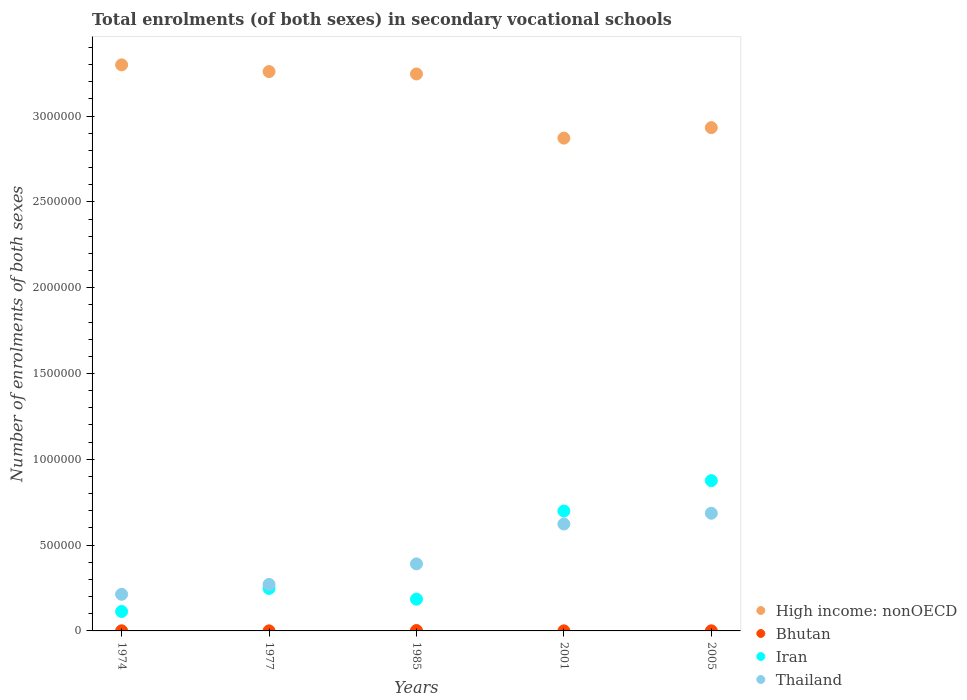How many different coloured dotlines are there?
Offer a very short reply. 4. Is the number of dotlines equal to the number of legend labels?
Your answer should be very brief. Yes. What is the number of enrolments in secondary schools in Bhutan in 2005?
Your response must be concise. 630. Across all years, what is the maximum number of enrolments in secondary schools in Thailand?
Your answer should be very brief. 6.86e+05. Across all years, what is the minimum number of enrolments in secondary schools in Thailand?
Give a very brief answer. 2.13e+05. In which year was the number of enrolments in secondary schools in Iran maximum?
Provide a succinct answer. 2005. In which year was the number of enrolments in secondary schools in Iran minimum?
Your answer should be compact. 1974. What is the total number of enrolments in secondary schools in Iran in the graph?
Give a very brief answer. 2.12e+06. What is the difference between the number of enrolments in secondary schools in High income: nonOECD in 1974 and that in 1985?
Offer a terse response. 5.31e+04. What is the difference between the number of enrolments in secondary schools in Thailand in 1985 and the number of enrolments in secondary schools in Bhutan in 2001?
Offer a very short reply. 3.90e+05. What is the average number of enrolments in secondary schools in Thailand per year?
Your answer should be very brief. 4.37e+05. In the year 2001, what is the difference between the number of enrolments in secondary schools in Bhutan and number of enrolments in secondary schools in High income: nonOECD?
Offer a terse response. -2.87e+06. In how many years, is the number of enrolments in secondary schools in Bhutan greater than 1400000?
Your answer should be very brief. 0. What is the ratio of the number of enrolments in secondary schools in Bhutan in 1974 to that in 2005?
Make the answer very short. 1.17. Is the number of enrolments in secondary schools in High income: nonOECD in 1974 less than that in 1977?
Keep it short and to the point. No. What is the difference between the highest and the second highest number of enrolments in secondary schools in Iran?
Provide a short and direct response. 1.77e+05. What is the difference between the highest and the lowest number of enrolments in secondary schools in Thailand?
Give a very brief answer. 4.72e+05. In how many years, is the number of enrolments in secondary schools in Bhutan greater than the average number of enrolments in secondary schools in Bhutan taken over all years?
Your answer should be compact. 1. Is the sum of the number of enrolments in secondary schools in Thailand in 1985 and 2005 greater than the maximum number of enrolments in secondary schools in Iran across all years?
Give a very brief answer. Yes. Is it the case that in every year, the sum of the number of enrolments in secondary schools in High income: nonOECD and number of enrolments in secondary schools in Bhutan  is greater than the number of enrolments in secondary schools in Thailand?
Your response must be concise. Yes. Does the number of enrolments in secondary schools in High income: nonOECD monotonically increase over the years?
Provide a succinct answer. No. Is the number of enrolments in secondary schools in Iran strictly less than the number of enrolments in secondary schools in High income: nonOECD over the years?
Keep it short and to the point. Yes. How many dotlines are there?
Your response must be concise. 4. How many years are there in the graph?
Give a very brief answer. 5. What is the difference between two consecutive major ticks on the Y-axis?
Give a very brief answer. 5.00e+05. Where does the legend appear in the graph?
Provide a short and direct response. Bottom right. What is the title of the graph?
Your answer should be very brief. Total enrolments (of both sexes) in secondary vocational schools. What is the label or title of the Y-axis?
Ensure brevity in your answer.  Number of enrolments of both sexes. What is the Number of enrolments of both sexes of High income: nonOECD in 1974?
Keep it short and to the point. 3.30e+06. What is the Number of enrolments of both sexes of Bhutan in 1974?
Keep it short and to the point. 734. What is the Number of enrolments of both sexes in Iran in 1974?
Your response must be concise. 1.13e+05. What is the Number of enrolments of both sexes in Thailand in 1974?
Offer a very short reply. 2.13e+05. What is the Number of enrolments of both sexes in High income: nonOECD in 1977?
Your answer should be compact. 3.26e+06. What is the Number of enrolments of both sexes of Bhutan in 1977?
Ensure brevity in your answer.  367. What is the Number of enrolments of both sexes of Iran in 1977?
Offer a terse response. 2.47e+05. What is the Number of enrolments of both sexes of Thailand in 1977?
Make the answer very short. 2.71e+05. What is the Number of enrolments of both sexes of High income: nonOECD in 1985?
Offer a terse response. 3.25e+06. What is the Number of enrolments of both sexes in Bhutan in 1985?
Give a very brief answer. 2314. What is the Number of enrolments of both sexes of Iran in 1985?
Offer a terse response. 1.85e+05. What is the Number of enrolments of both sexes of Thailand in 1985?
Your answer should be compact. 3.91e+05. What is the Number of enrolments of both sexes in High income: nonOECD in 2001?
Your response must be concise. 2.87e+06. What is the Number of enrolments of both sexes in Bhutan in 2001?
Ensure brevity in your answer.  444. What is the Number of enrolments of both sexes in Iran in 2001?
Your response must be concise. 6.99e+05. What is the Number of enrolments of both sexes in Thailand in 2001?
Offer a terse response. 6.23e+05. What is the Number of enrolments of both sexes in High income: nonOECD in 2005?
Provide a short and direct response. 2.93e+06. What is the Number of enrolments of both sexes in Bhutan in 2005?
Give a very brief answer. 630. What is the Number of enrolments of both sexes of Iran in 2005?
Provide a short and direct response. 8.76e+05. What is the Number of enrolments of both sexes of Thailand in 2005?
Keep it short and to the point. 6.86e+05. Across all years, what is the maximum Number of enrolments of both sexes in High income: nonOECD?
Your answer should be very brief. 3.30e+06. Across all years, what is the maximum Number of enrolments of both sexes in Bhutan?
Offer a very short reply. 2314. Across all years, what is the maximum Number of enrolments of both sexes in Iran?
Give a very brief answer. 8.76e+05. Across all years, what is the maximum Number of enrolments of both sexes of Thailand?
Offer a very short reply. 6.86e+05. Across all years, what is the minimum Number of enrolments of both sexes of High income: nonOECD?
Offer a very short reply. 2.87e+06. Across all years, what is the minimum Number of enrolments of both sexes of Bhutan?
Your answer should be compact. 367. Across all years, what is the minimum Number of enrolments of both sexes in Iran?
Your answer should be very brief. 1.13e+05. Across all years, what is the minimum Number of enrolments of both sexes in Thailand?
Your answer should be compact. 2.13e+05. What is the total Number of enrolments of both sexes of High income: nonOECD in the graph?
Keep it short and to the point. 1.56e+07. What is the total Number of enrolments of both sexes of Bhutan in the graph?
Keep it short and to the point. 4489. What is the total Number of enrolments of both sexes in Iran in the graph?
Offer a terse response. 2.12e+06. What is the total Number of enrolments of both sexes of Thailand in the graph?
Give a very brief answer. 2.18e+06. What is the difference between the Number of enrolments of both sexes in High income: nonOECD in 1974 and that in 1977?
Your response must be concise. 3.89e+04. What is the difference between the Number of enrolments of both sexes in Bhutan in 1974 and that in 1977?
Offer a very short reply. 367. What is the difference between the Number of enrolments of both sexes in Iran in 1974 and that in 1977?
Keep it short and to the point. -1.34e+05. What is the difference between the Number of enrolments of both sexes in Thailand in 1974 and that in 1977?
Offer a terse response. -5.75e+04. What is the difference between the Number of enrolments of both sexes in High income: nonOECD in 1974 and that in 1985?
Offer a very short reply. 5.31e+04. What is the difference between the Number of enrolments of both sexes in Bhutan in 1974 and that in 1985?
Provide a short and direct response. -1580. What is the difference between the Number of enrolments of both sexes of Iran in 1974 and that in 1985?
Your answer should be compact. -7.16e+04. What is the difference between the Number of enrolments of both sexes of Thailand in 1974 and that in 1985?
Ensure brevity in your answer.  -1.77e+05. What is the difference between the Number of enrolments of both sexes in High income: nonOECD in 1974 and that in 2001?
Offer a terse response. 4.27e+05. What is the difference between the Number of enrolments of both sexes of Bhutan in 1974 and that in 2001?
Offer a very short reply. 290. What is the difference between the Number of enrolments of both sexes in Iran in 1974 and that in 2001?
Offer a terse response. -5.85e+05. What is the difference between the Number of enrolments of both sexes of Thailand in 1974 and that in 2001?
Ensure brevity in your answer.  -4.10e+05. What is the difference between the Number of enrolments of both sexes in High income: nonOECD in 1974 and that in 2005?
Provide a short and direct response. 3.66e+05. What is the difference between the Number of enrolments of both sexes of Bhutan in 1974 and that in 2005?
Offer a terse response. 104. What is the difference between the Number of enrolments of both sexes in Iran in 1974 and that in 2005?
Your response must be concise. -7.62e+05. What is the difference between the Number of enrolments of both sexes in Thailand in 1974 and that in 2005?
Provide a short and direct response. -4.72e+05. What is the difference between the Number of enrolments of both sexes in High income: nonOECD in 1977 and that in 1985?
Give a very brief answer. 1.41e+04. What is the difference between the Number of enrolments of both sexes in Bhutan in 1977 and that in 1985?
Ensure brevity in your answer.  -1947. What is the difference between the Number of enrolments of both sexes in Iran in 1977 and that in 1985?
Make the answer very short. 6.25e+04. What is the difference between the Number of enrolments of both sexes of Thailand in 1977 and that in 1985?
Ensure brevity in your answer.  -1.20e+05. What is the difference between the Number of enrolments of both sexes of High income: nonOECD in 1977 and that in 2001?
Your answer should be compact. 3.88e+05. What is the difference between the Number of enrolments of both sexes in Bhutan in 1977 and that in 2001?
Your answer should be compact. -77. What is the difference between the Number of enrolments of both sexes in Iran in 1977 and that in 2001?
Your response must be concise. -4.51e+05. What is the difference between the Number of enrolments of both sexes in Thailand in 1977 and that in 2001?
Your answer should be compact. -3.52e+05. What is the difference between the Number of enrolments of both sexes of High income: nonOECD in 1977 and that in 2005?
Provide a short and direct response. 3.27e+05. What is the difference between the Number of enrolments of both sexes in Bhutan in 1977 and that in 2005?
Give a very brief answer. -263. What is the difference between the Number of enrolments of both sexes in Iran in 1977 and that in 2005?
Your answer should be very brief. -6.28e+05. What is the difference between the Number of enrolments of both sexes of Thailand in 1977 and that in 2005?
Ensure brevity in your answer.  -4.15e+05. What is the difference between the Number of enrolments of both sexes of High income: nonOECD in 1985 and that in 2001?
Your answer should be very brief. 3.74e+05. What is the difference between the Number of enrolments of both sexes in Bhutan in 1985 and that in 2001?
Provide a short and direct response. 1870. What is the difference between the Number of enrolments of both sexes of Iran in 1985 and that in 2001?
Provide a succinct answer. -5.14e+05. What is the difference between the Number of enrolments of both sexes in Thailand in 1985 and that in 2001?
Your answer should be compact. -2.32e+05. What is the difference between the Number of enrolments of both sexes in High income: nonOECD in 1985 and that in 2005?
Provide a succinct answer. 3.13e+05. What is the difference between the Number of enrolments of both sexes in Bhutan in 1985 and that in 2005?
Keep it short and to the point. 1684. What is the difference between the Number of enrolments of both sexes of Iran in 1985 and that in 2005?
Offer a very short reply. -6.91e+05. What is the difference between the Number of enrolments of both sexes in Thailand in 1985 and that in 2005?
Your answer should be compact. -2.95e+05. What is the difference between the Number of enrolments of both sexes in High income: nonOECD in 2001 and that in 2005?
Make the answer very short. -6.12e+04. What is the difference between the Number of enrolments of both sexes of Bhutan in 2001 and that in 2005?
Make the answer very short. -186. What is the difference between the Number of enrolments of both sexes of Iran in 2001 and that in 2005?
Provide a succinct answer. -1.77e+05. What is the difference between the Number of enrolments of both sexes of Thailand in 2001 and that in 2005?
Give a very brief answer. -6.27e+04. What is the difference between the Number of enrolments of both sexes of High income: nonOECD in 1974 and the Number of enrolments of both sexes of Bhutan in 1977?
Keep it short and to the point. 3.30e+06. What is the difference between the Number of enrolments of both sexes in High income: nonOECD in 1974 and the Number of enrolments of both sexes in Iran in 1977?
Your response must be concise. 3.05e+06. What is the difference between the Number of enrolments of both sexes of High income: nonOECD in 1974 and the Number of enrolments of both sexes of Thailand in 1977?
Make the answer very short. 3.03e+06. What is the difference between the Number of enrolments of both sexes in Bhutan in 1974 and the Number of enrolments of both sexes in Iran in 1977?
Offer a terse response. -2.47e+05. What is the difference between the Number of enrolments of both sexes in Bhutan in 1974 and the Number of enrolments of both sexes in Thailand in 1977?
Keep it short and to the point. -2.70e+05. What is the difference between the Number of enrolments of both sexes of Iran in 1974 and the Number of enrolments of both sexes of Thailand in 1977?
Your answer should be very brief. -1.58e+05. What is the difference between the Number of enrolments of both sexes of High income: nonOECD in 1974 and the Number of enrolments of both sexes of Bhutan in 1985?
Your answer should be compact. 3.30e+06. What is the difference between the Number of enrolments of both sexes in High income: nonOECD in 1974 and the Number of enrolments of both sexes in Iran in 1985?
Make the answer very short. 3.11e+06. What is the difference between the Number of enrolments of both sexes in High income: nonOECD in 1974 and the Number of enrolments of both sexes in Thailand in 1985?
Your answer should be compact. 2.91e+06. What is the difference between the Number of enrolments of both sexes of Bhutan in 1974 and the Number of enrolments of both sexes of Iran in 1985?
Offer a terse response. -1.84e+05. What is the difference between the Number of enrolments of both sexes in Bhutan in 1974 and the Number of enrolments of both sexes in Thailand in 1985?
Offer a terse response. -3.90e+05. What is the difference between the Number of enrolments of both sexes of Iran in 1974 and the Number of enrolments of both sexes of Thailand in 1985?
Offer a very short reply. -2.77e+05. What is the difference between the Number of enrolments of both sexes in High income: nonOECD in 1974 and the Number of enrolments of both sexes in Bhutan in 2001?
Keep it short and to the point. 3.30e+06. What is the difference between the Number of enrolments of both sexes in High income: nonOECD in 1974 and the Number of enrolments of both sexes in Iran in 2001?
Your answer should be very brief. 2.60e+06. What is the difference between the Number of enrolments of both sexes in High income: nonOECD in 1974 and the Number of enrolments of both sexes in Thailand in 2001?
Your answer should be compact. 2.68e+06. What is the difference between the Number of enrolments of both sexes in Bhutan in 1974 and the Number of enrolments of both sexes in Iran in 2001?
Give a very brief answer. -6.98e+05. What is the difference between the Number of enrolments of both sexes of Bhutan in 1974 and the Number of enrolments of both sexes of Thailand in 2001?
Ensure brevity in your answer.  -6.22e+05. What is the difference between the Number of enrolments of both sexes in Iran in 1974 and the Number of enrolments of both sexes in Thailand in 2001?
Ensure brevity in your answer.  -5.10e+05. What is the difference between the Number of enrolments of both sexes in High income: nonOECD in 1974 and the Number of enrolments of both sexes in Bhutan in 2005?
Your response must be concise. 3.30e+06. What is the difference between the Number of enrolments of both sexes of High income: nonOECD in 1974 and the Number of enrolments of both sexes of Iran in 2005?
Provide a succinct answer. 2.42e+06. What is the difference between the Number of enrolments of both sexes in High income: nonOECD in 1974 and the Number of enrolments of both sexes in Thailand in 2005?
Your answer should be very brief. 2.61e+06. What is the difference between the Number of enrolments of both sexes of Bhutan in 1974 and the Number of enrolments of both sexes of Iran in 2005?
Offer a very short reply. -8.75e+05. What is the difference between the Number of enrolments of both sexes in Bhutan in 1974 and the Number of enrolments of both sexes in Thailand in 2005?
Keep it short and to the point. -6.85e+05. What is the difference between the Number of enrolments of both sexes of Iran in 1974 and the Number of enrolments of both sexes of Thailand in 2005?
Provide a succinct answer. -5.72e+05. What is the difference between the Number of enrolments of both sexes in High income: nonOECD in 1977 and the Number of enrolments of both sexes in Bhutan in 1985?
Give a very brief answer. 3.26e+06. What is the difference between the Number of enrolments of both sexes in High income: nonOECD in 1977 and the Number of enrolments of both sexes in Iran in 1985?
Make the answer very short. 3.07e+06. What is the difference between the Number of enrolments of both sexes of High income: nonOECD in 1977 and the Number of enrolments of both sexes of Thailand in 1985?
Ensure brevity in your answer.  2.87e+06. What is the difference between the Number of enrolments of both sexes in Bhutan in 1977 and the Number of enrolments of both sexes in Iran in 1985?
Your answer should be very brief. -1.85e+05. What is the difference between the Number of enrolments of both sexes in Bhutan in 1977 and the Number of enrolments of both sexes in Thailand in 1985?
Provide a succinct answer. -3.90e+05. What is the difference between the Number of enrolments of both sexes of Iran in 1977 and the Number of enrolments of both sexes of Thailand in 1985?
Provide a short and direct response. -1.43e+05. What is the difference between the Number of enrolments of both sexes in High income: nonOECD in 1977 and the Number of enrolments of both sexes in Bhutan in 2001?
Your response must be concise. 3.26e+06. What is the difference between the Number of enrolments of both sexes of High income: nonOECD in 1977 and the Number of enrolments of both sexes of Iran in 2001?
Make the answer very short. 2.56e+06. What is the difference between the Number of enrolments of both sexes in High income: nonOECD in 1977 and the Number of enrolments of both sexes in Thailand in 2001?
Give a very brief answer. 2.64e+06. What is the difference between the Number of enrolments of both sexes of Bhutan in 1977 and the Number of enrolments of both sexes of Iran in 2001?
Keep it short and to the point. -6.98e+05. What is the difference between the Number of enrolments of both sexes in Bhutan in 1977 and the Number of enrolments of both sexes in Thailand in 2001?
Make the answer very short. -6.23e+05. What is the difference between the Number of enrolments of both sexes of Iran in 1977 and the Number of enrolments of both sexes of Thailand in 2001?
Your answer should be very brief. -3.76e+05. What is the difference between the Number of enrolments of both sexes of High income: nonOECD in 1977 and the Number of enrolments of both sexes of Bhutan in 2005?
Make the answer very short. 3.26e+06. What is the difference between the Number of enrolments of both sexes in High income: nonOECD in 1977 and the Number of enrolments of both sexes in Iran in 2005?
Your answer should be compact. 2.38e+06. What is the difference between the Number of enrolments of both sexes in High income: nonOECD in 1977 and the Number of enrolments of both sexes in Thailand in 2005?
Ensure brevity in your answer.  2.57e+06. What is the difference between the Number of enrolments of both sexes of Bhutan in 1977 and the Number of enrolments of both sexes of Iran in 2005?
Your answer should be compact. -8.75e+05. What is the difference between the Number of enrolments of both sexes of Bhutan in 1977 and the Number of enrolments of both sexes of Thailand in 2005?
Make the answer very short. -6.85e+05. What is the difference between the Number of enrolments of both sexes of Iran in 1977 and the Number of enrolments of both sexes of Thailand in 2005?
Make the answer very short. -4.38e+05. What is the difference between the Number of enrolments of both sexes of High income: nonOECD in 1985 and the Number of enrolments of both sexes of Bhutan in 2001?
Give a very brief answer. 3.25e+06. What is the difference between the Number of enrolments of both sexes of High income: nonOECD in 1985 and the Number of enrolments of both sexes of Iran in 2001?
Give a very brief answer. 2.55e+06. What is the difference between the Number of enrolments of both sexes in High income: nonOECD in 1985 and the Number of enrolments of both sexes in Thailand in 2001?
Your answer should be very brief. 2.62e+06. What is the difference between the Number of enrolments of both sexes in Bhutan in 1985 and the Number of enrolments of both sexes in Iran in 2001?
Provide a succinct answer. -6.96e+05. What is the difference between the Number of enrolments of both sexes of Bhutan in 1985 and the Number of enrolments of both sexes of Thailand in 2001?
Provide a short and direct response. -6.21e+05. What is the difference between the Number of enrolments of both sexes of Iran in 1985 and the Number of enrolments of both sexes of Thailand in 2001?
Offer a terse response. -4.38e+05. What is the difference between the Number of enrolments of both sexes in High income: nonOECD in 1985 and the Number of enrolments of both sexes in Bhutan in 2005?
Give a very brief answer. 3.24e+06. What is the difference between the Number of enrolments of both sexes of High income: nonOECD in 1985 and the Number of enrolments of both sexes of Iran in 2005?
Offer a very short reply. 2.37e+06. What is the difference between the Number of enrolments of both sexes of High income: nonOECD in 1985 and the Number of enrolments of both sexes of Thailand in 2005?
Offer a very short reply. 2.56e+06. What is the difference between the Number of enrolments of both sexes of Bhutan in 1985 and the Number of enrolments of both sexes of Iran in 2005?
Your answer should be compact. -8.74e+05. What is the difference between the Number of enrolments of both sexes in Bhutan in 1985 and the Number of enrolments of both sexes in Thailand in 2005?
Provide a succinct answer. -6.83e+05. What is the difference between the Number of enrolments of both sexes in Iran in 1985 and the Number of enrolments of both sexes in Thailand in 2005?
Keep it short and to the point. -5.01e+05. What is the difference between the Number of enrolments of both sexes of High income: nonOECD in 2001 and the Number of enrolments of both sexes of Bhutan in 2005?
Your answer should be very brief. 2.87e+06. What is the difference between the Number of enrolments of both sexes in High income: nonOECD in 2001 and the Number of enrolments of both sexes in Iran in 2005?
Make the answer very short. 2.00e+06. What is the difference between the Number of enrolments of both sexes of High income: nonOECD in 2001 and the Number of enrolments of both sexes of Thailand in 2005?
Provide a succinct answer. 2.19e+06. What is the difference between the Number of enrolments of both sexes in Bhutan in 2001 and the Number of enrolments of both sexes in Iran in 2005?
Make the answer very short. -8.75e+05. What is the difference between the Number of enrolments of both sexes of Bhutan in 2001 and the Number of enrolments of both sexes of Thailand in 2005?
Give a very brief answer. -6.85e+05. What is the difference between the Number of enrolments of both sexes of Iran in 2001 and the Number of enrolments of both sexes of Thailand in 2005?
Provide a succinct answer. 1.30e+04. What is the average Number of enrolments of both sexes of High income: nonOECD per year?
Your answer should be very brief. 3.12e+06. What is the average Number of enrolments of both sexes of Bhutan per year?
Make the answer very short. 897.8. What is the average Number of enrolments of both sexes in Iran per year?
Ensure brevity in your answer.  4.24e+05. What is the average Number of enrolments of both sexes of Thailand per year?
Offer a very short reply. 4.37e+05. In the year 1974, what is the difference between the Number of enrolments of both sexes in High income: nonOECD and Number of enrolments of both sexes in Bhutan?
Ensure brevity in your answer.  3.30e+06. In the year 1974, what is the difference between the Number of enrolments of both sexes in High income: nonOECD and Number of enrolments of both sexes in Iran?
Give a very brief answer. 3.19e+06. In the year 1974, what is the difference between the Number of enrolments of both sexes of High income: nonOECD and Number of enrolments of both sexes of Thailand?
Your answer should be very brief. 3.09e+06. In the year 1974, what is the difference between the Number of enrolments of both sexes of Bhutan and Number of enrolments of both sexes of Iran?
Provide a short and direct response. -1.13e+05. In the year 1974, what is the difference between the Number of enrolments of both sexes of Bhutan and Number of enrolments of both sexes of Thailand?
Offer a terse response. -2.13e+05. In the year 1974, what is the difference between the Number of enrolments of both sexes of Iran and Number of enrolments of both sexes of Thailand?
Provide a succinct answer. -1.00e+05. In the year 1977, what is the difference between the Number of enrolments of both sexes of High income: nonOECD and Number of enrolments of both sexes of Bhutan?
Offer a very short reply. 3.26e+06. In the year 1977, what is the difference between the Number of enrolments of both sexes in High income: nonOECD and Number of enrolments of both sexes in Iran?
Give a very brief answer. 3.01e+06. In the year 1977, what is the difference between the Number of enrolments of both sexes of High income: nonOECD and Number of enrolments of both sexes of Thailand?
Ensure brevity in your answer.  2.99e+06. In the year 1977, what is the difference between the Number of enrolments of both sexes in Bhutan and Number of enrolments of both sexes in Iran?
Ensure brevity in your answer.  -2.47e+05. In the year 1977, what is the difference between the Number of enrolments of both sexes of Bhutan and Number of enrolments of both sexes of Thailand?
Your answer should be compact. -2.71e+05. In the year 1977, what is the difference between the Number of enrolments of both sexes in Iran and Number of enrolments of both sexes in Thailand?
Give a very brief answer. -2.34e+04. In the year 1985, what is the difference between the Number of enrolments of both sexes of High income: nonOECD and Number of enrolments of both sexes of Bhutan?
Your answer should be compact. 3.24e+06. In the year 1985, what is the difference between the Number of enrolments of both sexes of High income: nonOECD and Number of enrolments of both sexes of Iran?
Your answer should be very brief. 3.06e+06. In the year 1985, what is the difference between the Number of enrolments of both sexes of High income: nonOECD and Number of enrolments of both sexes of Thailand?
Provide a short and direct response. 2.85e+06. In the year 1985, what is the difference between the Number of enrolments of both sexes of Bhutan and Number of enrolments of both sexes of Iran?
Make the answer very short. -1.83e+05. In the year 1985, what is the difference between the Number of enrolments of both sexes of Bhutan and Number of enrolments of both sexes of Thailand?
Provide a short and direct response. -3.88e+05. In the year 1985, what is the difference between the Number of enrolments of both sexes of Iran and Number of enrolments of both sexes of Thailand?
Your answer should be compact. -2.06e+05. In the year 2001, what is the difference between the Number of enrolments of both sexes of High income: nonOECD and Number of enrolments of both sexes of Bhutan?
Provide a short and direct response. 2.87e+06. In the year 2001, what is the difference between the Number of enrolments of both sexes of High income: nonOECD and Number of enrolments of both sexes of Iran?
Your response must be concise. 2.17e+06. In the year 2001, what is the difference between the Number of enrolments of both sexes of High income: nonOECD and Number of enrolments of both sexes of Thailand?
Provide a succinct answer. 2.25e+06. In the year 2001, what is the difference between the Number of enrolments of both sexes in Bhutan and Number of enrolments of both sexes in Iran?
Your answer should be compact. -6.98e+05. In the year 2001, what is the difference between the Number of enrolments of both sexes of Bhutan and Number of enrolments of both sexes of Thailand?
Your response must be concise. -6.23e+05. In the year 2001, what is the difference between the Number of enrolments of both sexes in Iran and Number of enrolments of both sexes in Thailand?
Offer a very short reply. 7.57e+04. In the year 2005, what is the difference between the Number of enrolments of both sexes in High income: nonOECD and Number of enrolments of both sexes in Bhutan?
Ensure brevity in your answer.  2.93e+06. In the year 2005, what is the difference between the Number of enrolments of both sexes in High income: nonOECD and Number of enrolments of both sexes in Iran?
Provide a short and direct response. 2.06e+06. In the year 2005, what is the difference between the Number of enrolments of both sexes of High income: nonOECD and Number of enrolments of both sexes of Thailand?
Offer a terse response. 2.25e+06. In the year 2005, what is the difference between the Number of enrolments of both sexes of Bhutan and Number of enrolments of both sexes of Iran?
Your response must be concise. -8.75e+05. In the year 2005, what is the difference between the Number of enrolments of both sexes of Bhutan and Number of enrolments of both sexes of Thailand?
Give a very brief answer. -6.85e+05. In the year 2005, what is the difference between the Number of enrolments of both sexes in Iran and Number of enrolments of both sexes in Thailand?
Your response must be concise. 1.90e+05. What is the ratio of the Number of enrolments of both sexes in High income: nonOECD in 1974 to that in 1977?
Offer a terse response. 1.01. What is the ratio of the Number of enrolments of both sexes in Iran in 1974 to that in 1977?
Make the answer very short. 0.46. What is the ratio of the Number of enrolments of both sexes of Thailand in 1974 to that in 1977?
Make the answer very short. 0.79. What is the ratio of the Number of enrolments of both sexes of High income: nonOECD in 1974 to that in 1985?
Provide a short and direct response. 1.02. What is the ratio of the Number of enrolments of both sexes of Bhutan in 1974 to that in 1985?
Offer a very short reply. 0.32. What is the ratio of the Number of enrolments of both sexes of Iran in 1974 to that in 1985?
Your answer should be very brief. 0.61. What is the ratio of the Number of enrolments of both sexes of Thailand in 1974 to that in 1985?
Offer a terse response. 0.55. What is the ratio of the Number of enrolments of both sexes in High income: nonOECD in 1974 to that in 2001?
Your response must be concise. 1.15. What is the ratio of the Number of enrolments of both sexes of Bhutan in 1974 to that in 2001?
Provide a short and direct response. 1.65. What is the ratio of the Number of enrolments of both sexes in Iran in 1974 to that in 2001?
Offer a terse response. 0.16. What is the ratio of the Number of enrolments of both sexes in Thailand in 1974 to that in 2001?
Offer a terse response. 0.34. What is the ratio of the Number of enrolments of both sexes in High income: nonOECD in 1974 to that in 2005?
Give a very brief answer. 1.12. What is the ratio of the Number of enrolments of both sexes of Bhutan in 1974 to that in 2005?
Keep it short and to the point. 1.17. What is the ratio of the Number of enrolments of both sexes in Iran in 1974 to that in 2005?
Ensure brevity in your answer.  0.13. What is the ratio of the Number of enrolments of both sexes of Thailand in 1974 to that in 2005?
Your response must be concise. 0.31. What is the ratio of the Number of enrolments of both sexes in Bhutan in 1977 to that in 1985?
Provide a succinct answer. 0.16. What is the ratio of the Number of enrolments of both sexes in Iran in 1977 to that in 1985?
Your response must be concise. 1.34. What is the ratio of the Number of enrolments of both sexes in Thailand in 1977 to that in 1985?
Make the answer very short. 0.69. What is the ratio of the Number of enrolments of both sexes in High income: nonOECD in 1977 to that in 2001?
Offer a very short reply. 1.14. What is the ratio of the Number of enrolments of both sexes in Bhutan in 1977 to that in 2001?
Ensure brevity in your answer.  0.83. What is the ratio of the Number of enrolments of both sexes of Iran in 1977 to that in 2001?
Provide a short and direct response. 0.35. What is the ratio of the Number of enrolments of both sexes in Thailand in 1977 to that in 2001?
Offer a very short reply. 0.43. What is the ratio of the Number of enrolments of both sexes of High income: nonOECD in 1977 to that in 2005?
Give a very brief answer. 1.11. What is the ratio of the Number of enrolments of both sexes of Bhutan in 1977 to that in 2005?
Give a very brief answer. 0.58. What is the ratio of the Number of enrolments of both sexes in Iran in 1977 to that in 2005?
Offer a terse response. 0.28. What is the ratio of the Number of enrolments of both sexes of Thailand in 1977 to that in 2005?
Your answer should be compact. 0.4. What is the ratio of the Number of enrolments of both sexes in High income: nonOECD in 1985 to that in 2001?
Offer a terse response. 1.13. What is the ratio of the Number of enrolments of both sexes of Bhutan in 1985 to that in 2001?
Your answer should be compact. 5.21. What is the ratio of the Number of enrolments of both sexes in Iran in 1985 to that in 2001?
Your response must be concise. 0.26. What is the ratio of the Number of enrolments of both sexes in Thailand in 1985 to that in 2001?
Keep it short and to the point. 0.63. What is the ratio of the Number of enrolments of both sexes in High income: nonOECD in 1985 to that in 2005?
Keep it short and to the point. 1.11. What is the ratio of the Number of enrolments of both sexes in Bhutan in 1985 to that in 2005?
Provide a succinct answer. 3.67. What is the ratio of the Number of enrolments of both sexes of Iran in 1985 to that in 2005?
Your response must be concise. 0.21. What is the ratio of the Number of enrolments of both sexes of Thailand in 1985 to that in 2005?
Your answer should be very brief. 0.57. What is the ratio of the Number of enrolments of both sexes of High income: nonOECD in 2001 to that in 2005?
Make the answer very short. 0.98. What is the ratio of the Number of enrolments of both sexes of Bhutan in 2001 to that in 2005?
Keep it short and to the point. 0.7. What is the ratio of the Number of enrolments of both sexes of Iran in 2001 to that in 2005?
Give a very brief answer. 0.8. What is the ratio of the Number of enrolments of both sexes of Thailand in 2001 to that in 2005?
Provide a succinct answer. 0.91. What is the difference between the highest and the second highest Number of enrolments of both sexes of High income: nonOECD?
Make the answer very short. 3.89e+04. What is the difference between the highest and the second highest Number of enrolments of both sexes in Bhutan?
Keep it short and to the point. 1580. What is the difference between the highest and the second highest Number of enrolments of both sexes of Iran?
Make the answer very short. 1.77e+05. What is the difference between the highest and the second highest Number of enrolments of both sexes of Thailand?
Your answer should be very brief. 6.27e+04. What is the difference between the highest and the lowest Number of enrolments of both sexes in High income: nonOECD?
Provide a short and direct response. 4.27e+05. What is the difference between the highest and the lowest Number of enrolments of both sexes in Bhutan?
Provide a short and direct response. 1947. What is the difference between the highest and the lowest Number of enrolments of both sexes in Iran?
Offer a terse response. 7.62e+05. What is the difference between the highest and the lowest Number of enrolments of both sexes of Thailand?
Make the answer very short. 4.72e+05. 